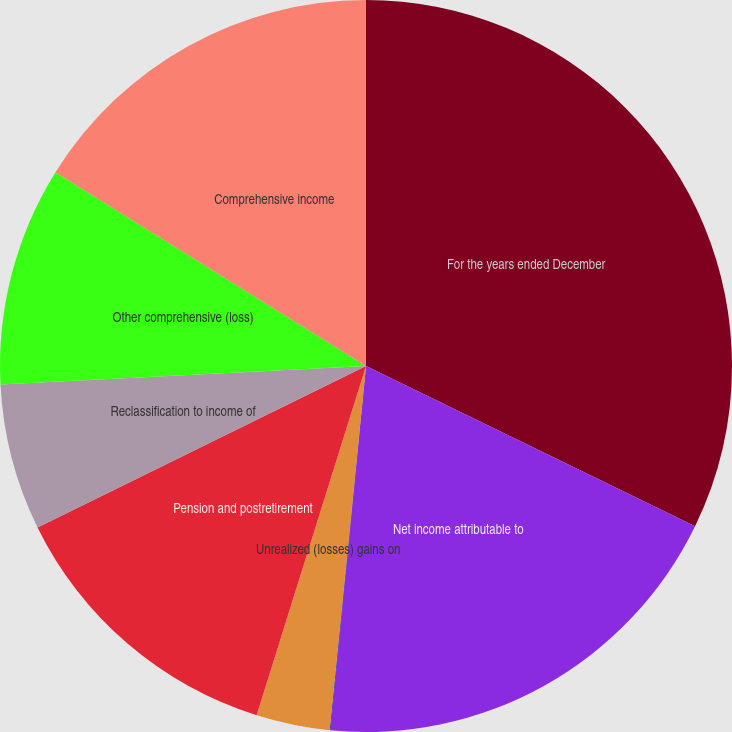Convert chart to OTSL. <chart><loc_0><loc_0><loc_500><loc_500><pie_chart><fcel>For the years ended December<fcel>Net income attributable to<fcel>Foreign currency translation<fcel>Unrealized (losses) gains on<fcel>Pension and postretirement<fcel>Reclassification to income of<fcel>Other comprehensive (loss)<fcel>Comprehensive income<nl><fcel>32.21%<fcel>19.34%<fcel>0.03%<fcel>3.25%<fcel>12.9%<fcel>6.47%<fcel>9.68%<fcel>16.12%<nl></chart> 